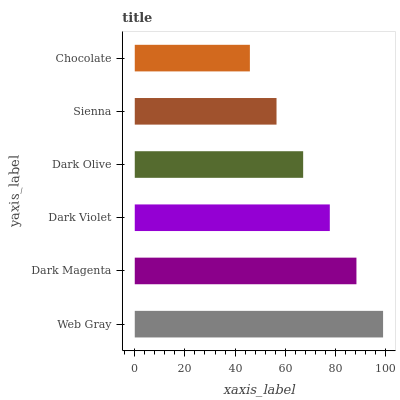Is Chocolate the minimum?
Answer yes or no. Yes. Is Web Gray the maximum?
Answer yes or no. Yes. Is Dark Magenta the minimum?
Answer yes or no. No. Is Dark Magenta the maximum?
Answer yes or no. No. Is Web Gray greater than Dark Magenta?
Answer yes or no. Yes. Is Dark Magenta less than Web Gray?
Answer yes or no. Yes. Is Dark Magenta greater than Web Gray?
Answer yes or no. No. Is Web Gray less than Dark Magenta?
Answer yes or no. No. Is Dark Violet the high median?
Answer yes or no. Yes. Is Dark Olive the low median?
Answer yes or no. Yes. Is Dark Olive the high median?
Answer yes or no. No. Is Sienna the low median?
Answer yes or no. No. 